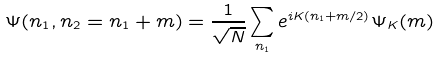<formula> <loc_0><loc_0><loc_500><loc_500>\Psi ( n _ { 1 } , n _ { 2 } = n _ { 1 } + m ) = \frac { 1 } { \sqrt { N } } \sum _ { n _ { 1 } } e ^ { i K ( n _ { 1 } + m / 2 ) } \Psi _ { K } ( m )</formula> 